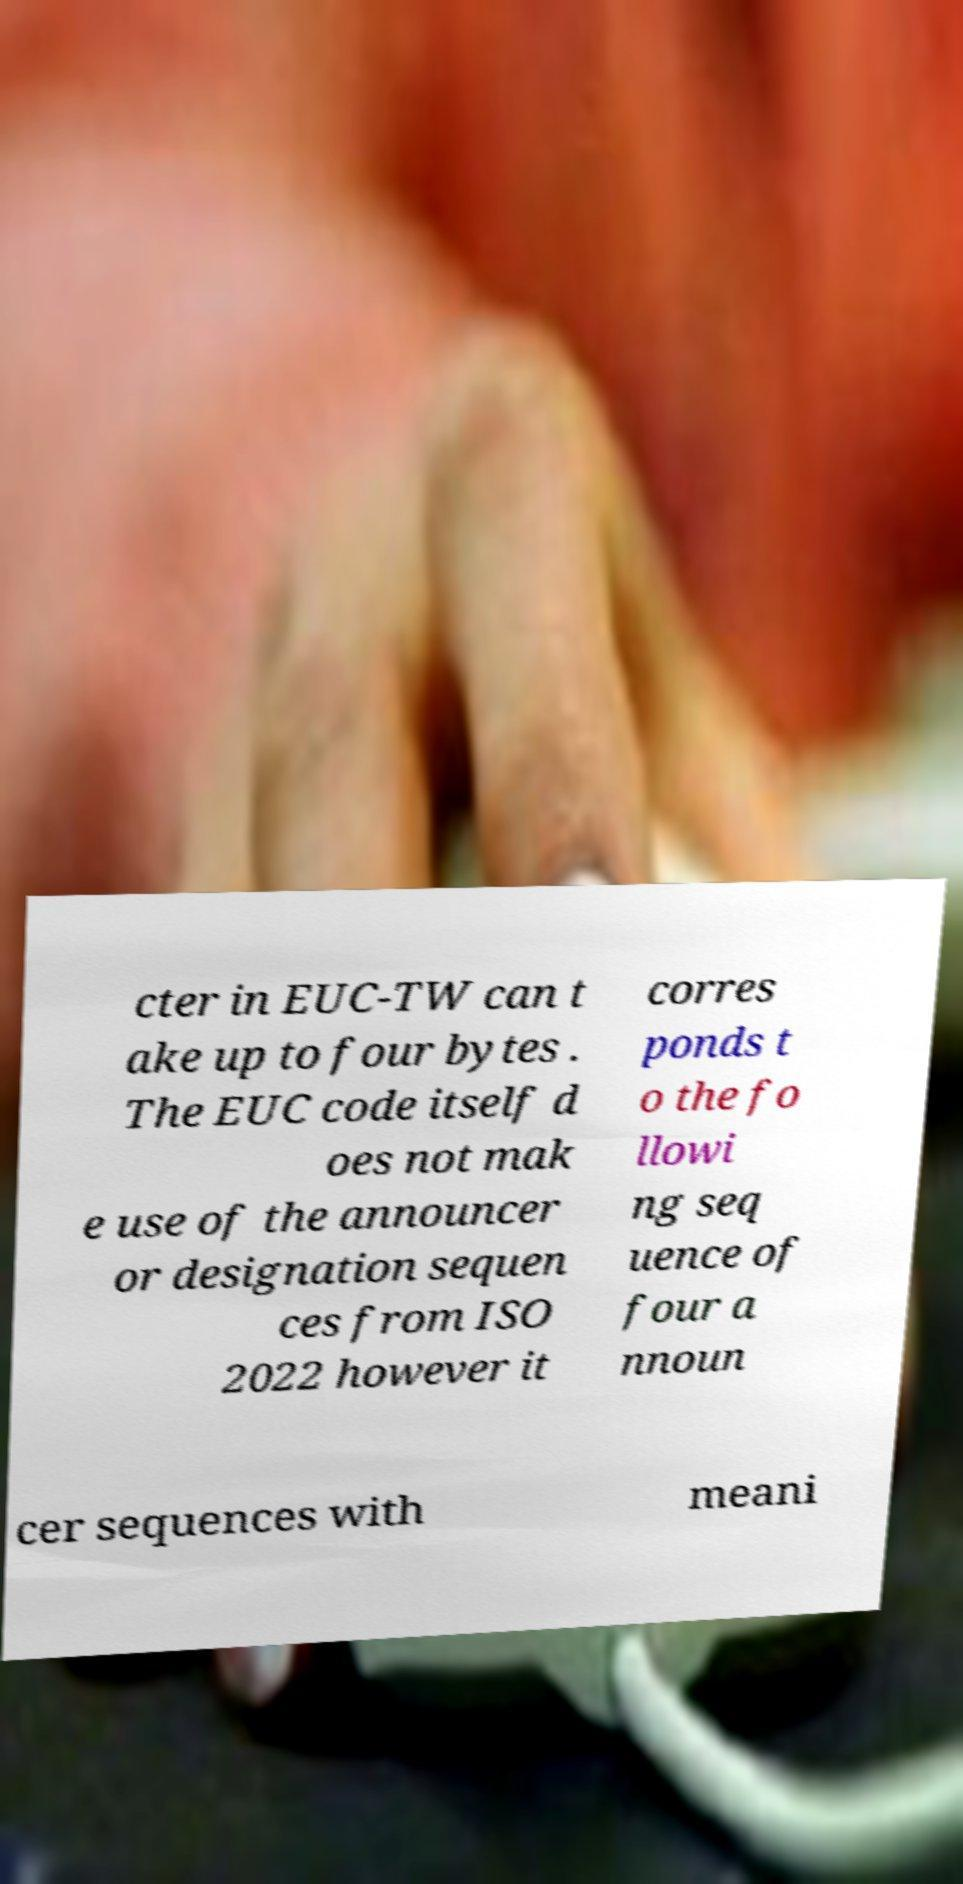Could you assist in decoding the text presented in this image and type it out clearly? cter in EUC-TW can t ake up to four bytes . The EUC code itself d oes not mak e use of the announcer or designation sequen ces from ISO 2022 however it corres ponds t o the fo llowi ng seq uence of four a nnoun cer sequences with meani 